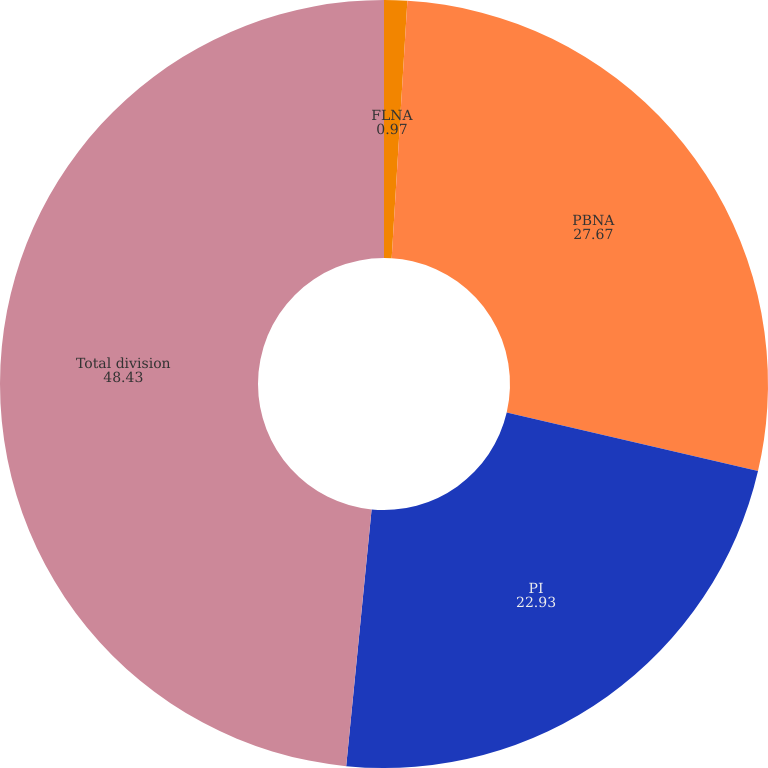Convert chart. <chart><loc_0><loc_0><loc_500><loc_500><pie_chart><fcel>FLNA<fcel>PBNA<fcel>PI<fcel>Total division<nl><fcel>0.97%<fcel>27.67%<fcel>22.93%<fcel>48.43%<nl></chart> 